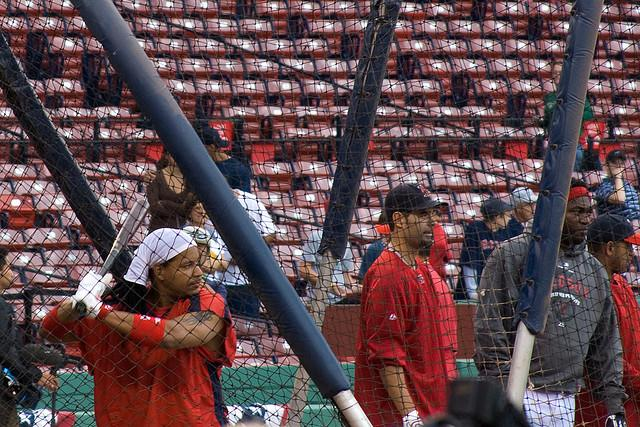Which base ball sport equipment is made up with maple wood?

Choices:
A) bat
B) ball
C) net
D) cap bat 